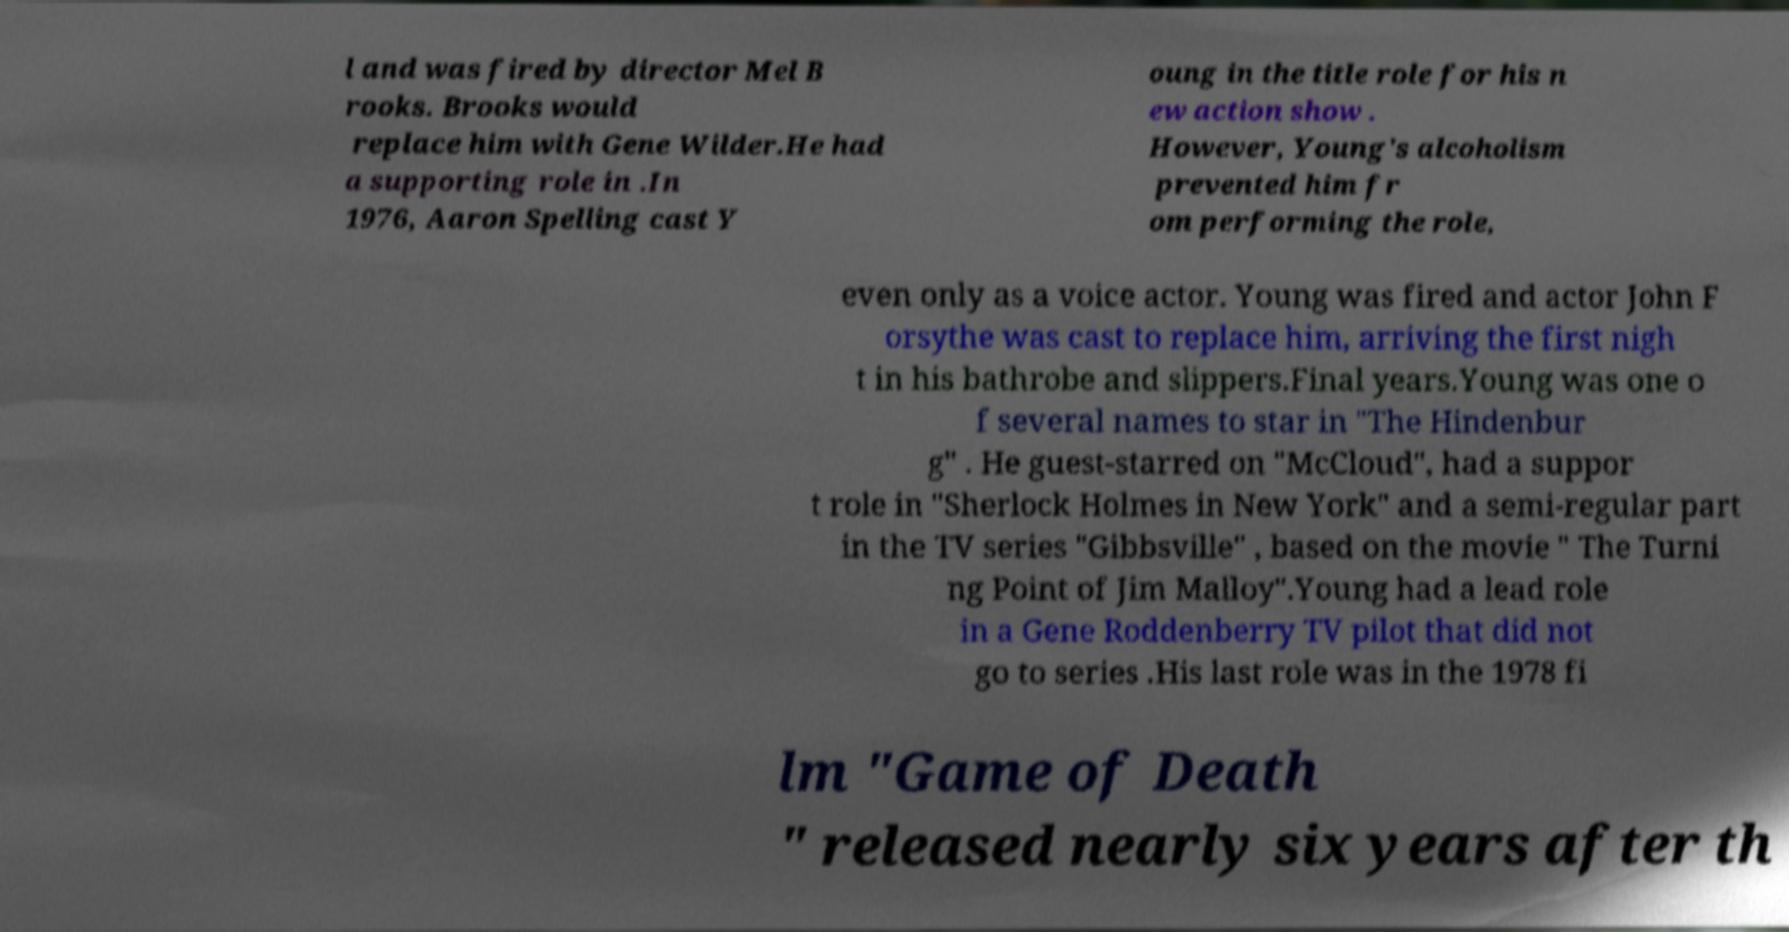Can you read and provide the text displayed in the image?This photo seems to have some interesting text. Can you extract and type it out for me? l and was fired by director Mel B rooks. Brooks would replace him with Gene Wilder.He had a supporting role in .In 1976, Aaron Spelling cast Y oung in the title role for his n ew action show . However, Young's alcoholism prevented him fr om performing the role, even only as a voice actor. Young was fired and actor John F orsythe was cast to replace him, arriving the first nigh t in his bathrobe and slippers.Final years.Young was one o f several names to star in "The Hindenbur g" . He guest-starred on "McCloud", had a suppor t role in "Sherlock Holmes in New York" and a semi-regular part in the TV series "Gibbsville" , based on the movie " The Turni ng Point of Jim Malloy".Young had a lead role in a Gene Roddenberry TV pilot that did not go to series .His last role was in the 1978 fi lm "Game of Death " released nearly six years after th 